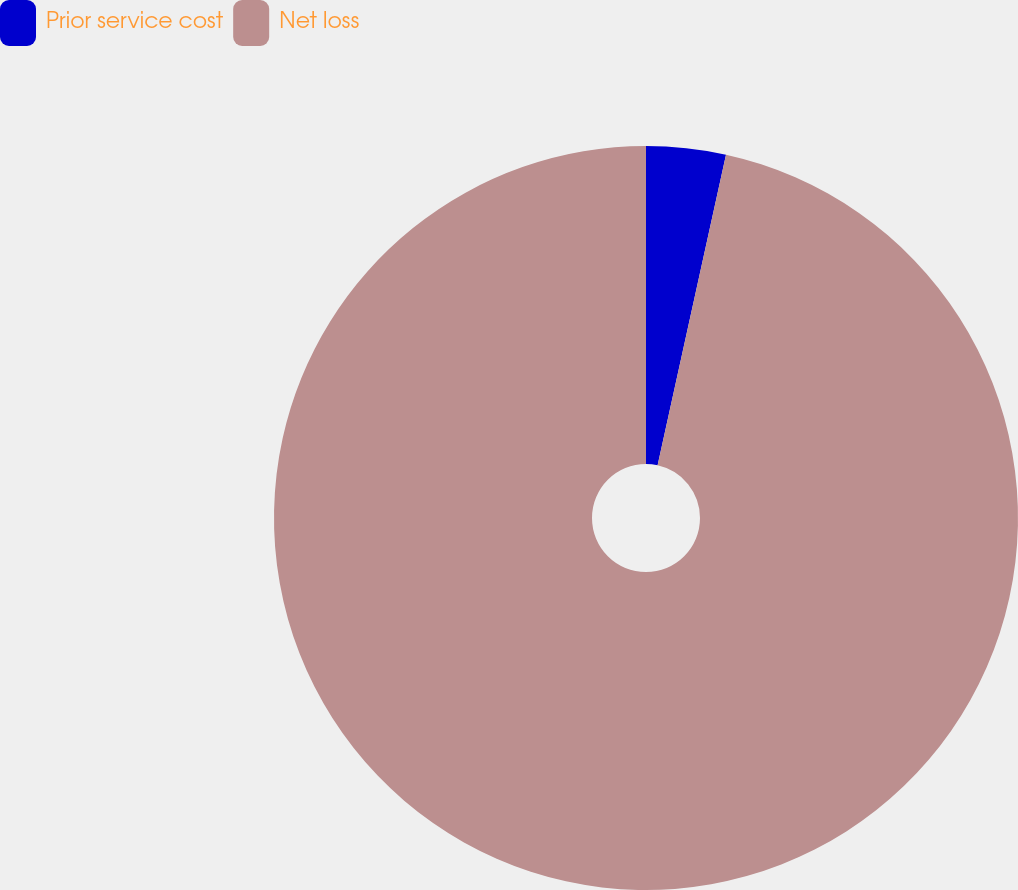Convert chart. <chart><loc_0><loc_0><loc_500><loc_500><pie_chart><fcel>Prior service cost<fcel>Net loss<nl><fcel>3.45%<fcel>96.55%<nl></chart> 